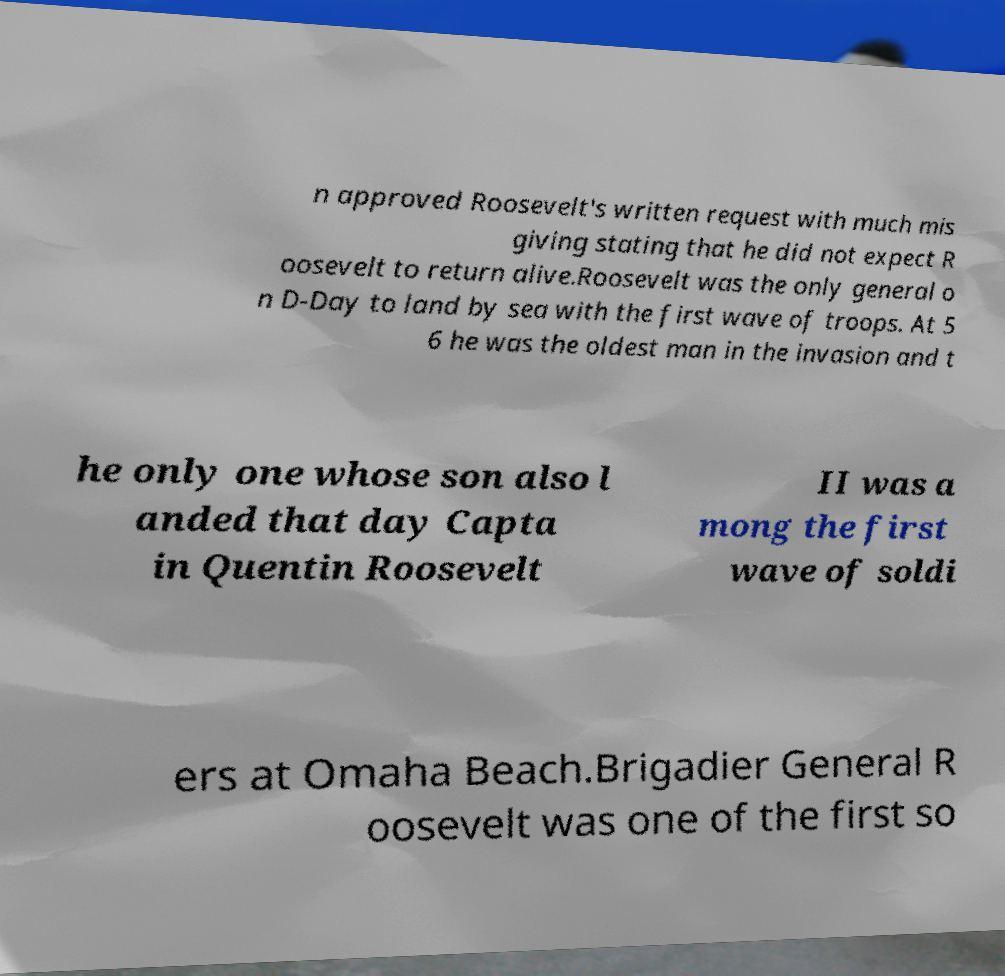What messages or text are displayed in this image? I need them in a readable, typed format. n approved Roosevelt's written request with much mis giving stating that he did not expect R oosevelt to return alive.Roosevelt was the only general o n D-Day to land by sea with the first wave of troops. At 5 6 he was the oldest man in the invasion and t he only one whose son also l anded that day Capta in Quentin Roosevelt II was a mong the first wave of soldi ers at Omaha Beach.Brigadier General R oosevelt was one of the first so 